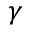<formula> <loc_0><loc_0><loc_500><loc_500>\gamma</formula> 